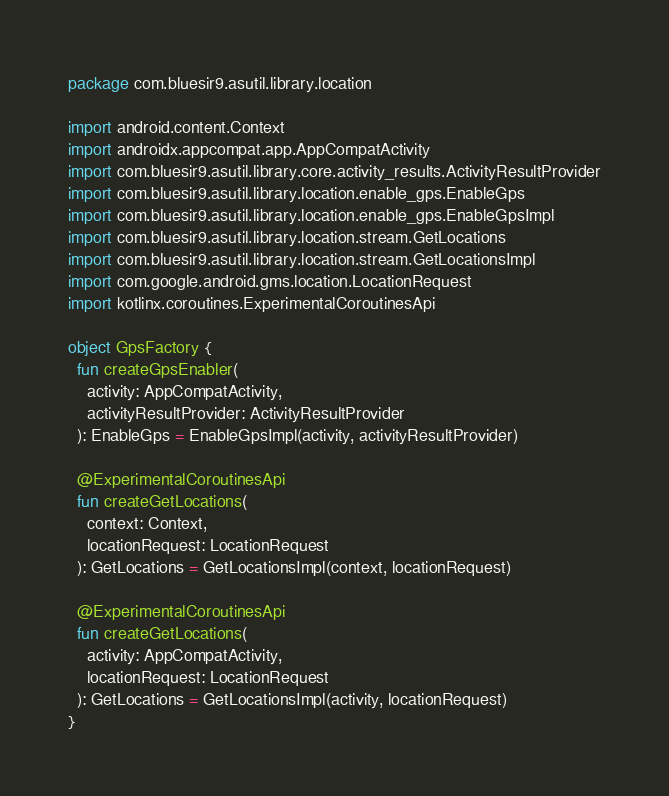<code> <loc_0><loc_0><loc_500><loc_500><_Kotlin_>package com.bluesir9.asutil.library.location

import android.content.Context
import androidx.appcompat.app.AppCompatActivity
import com.bluesir9.asutil.library.core.activity_results.ActivityResultProvider
import com.bluesir9.asutil.library.location.enable_gps.EnableGps
import com.bluesir9.asutil.library.location.enable_gps.EnableGpsImpl
import com.bluesir9.asutil.library.location.stream.GetLocations
import com.bluesir9.asutil.library.location.stream.GetLocationsImpl
import com.google.android.gms.location.LocationRequest
import kotlinx.coroutines.ExperimentalCoroutinesApi

object GpsFactory {
  fun createGpsEnabler(
    activity: AppCompatActivity,
    activityResultProvider: ActivityResultProvider
  ): EnableGps = EnableGpsImpl(activity, activityResultProvider)

  @ExperimentalCoroutinesApi
  fun createGetLocations(
    context: Context,
    locationRequest: LocationRequest
  ): GetLocations = GetLocationsImpl(context, locationRequest)

  @ExperimentalCoroutinesApi
  fun createGetLocations(
    activity: AppCompatActivity,
    locationRequest: LocationRequest
  ): GetLocations = GetLocationsImpl(activity, locationRequest)
}</code> 